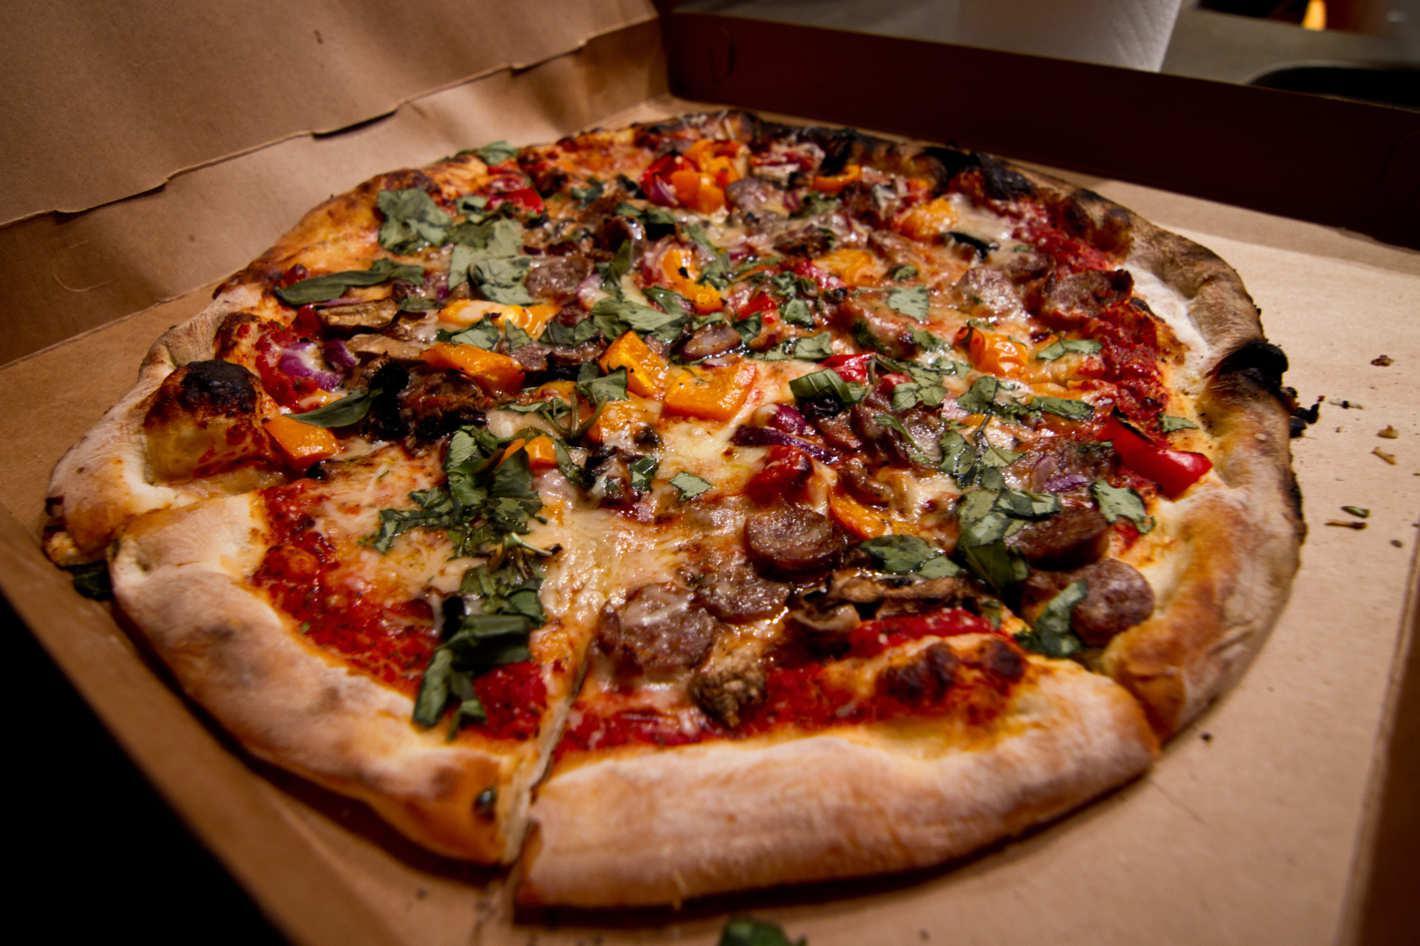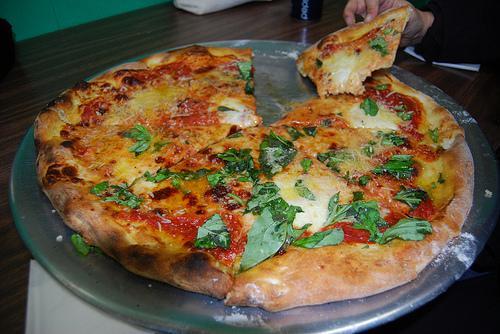The first image is the image on the left, the second image is the image on the right. For the images shown, is this caption "In at least one of the images, there's a single pizza on a metal pan." true? Answer yes or no. Yes. The first image is the image on the left, the second image is the image on the right. For the images shown, is this caption "A person is holding a round-bladed cutting tool over a round pizza in the right image." true? Answer yes or no. No. 